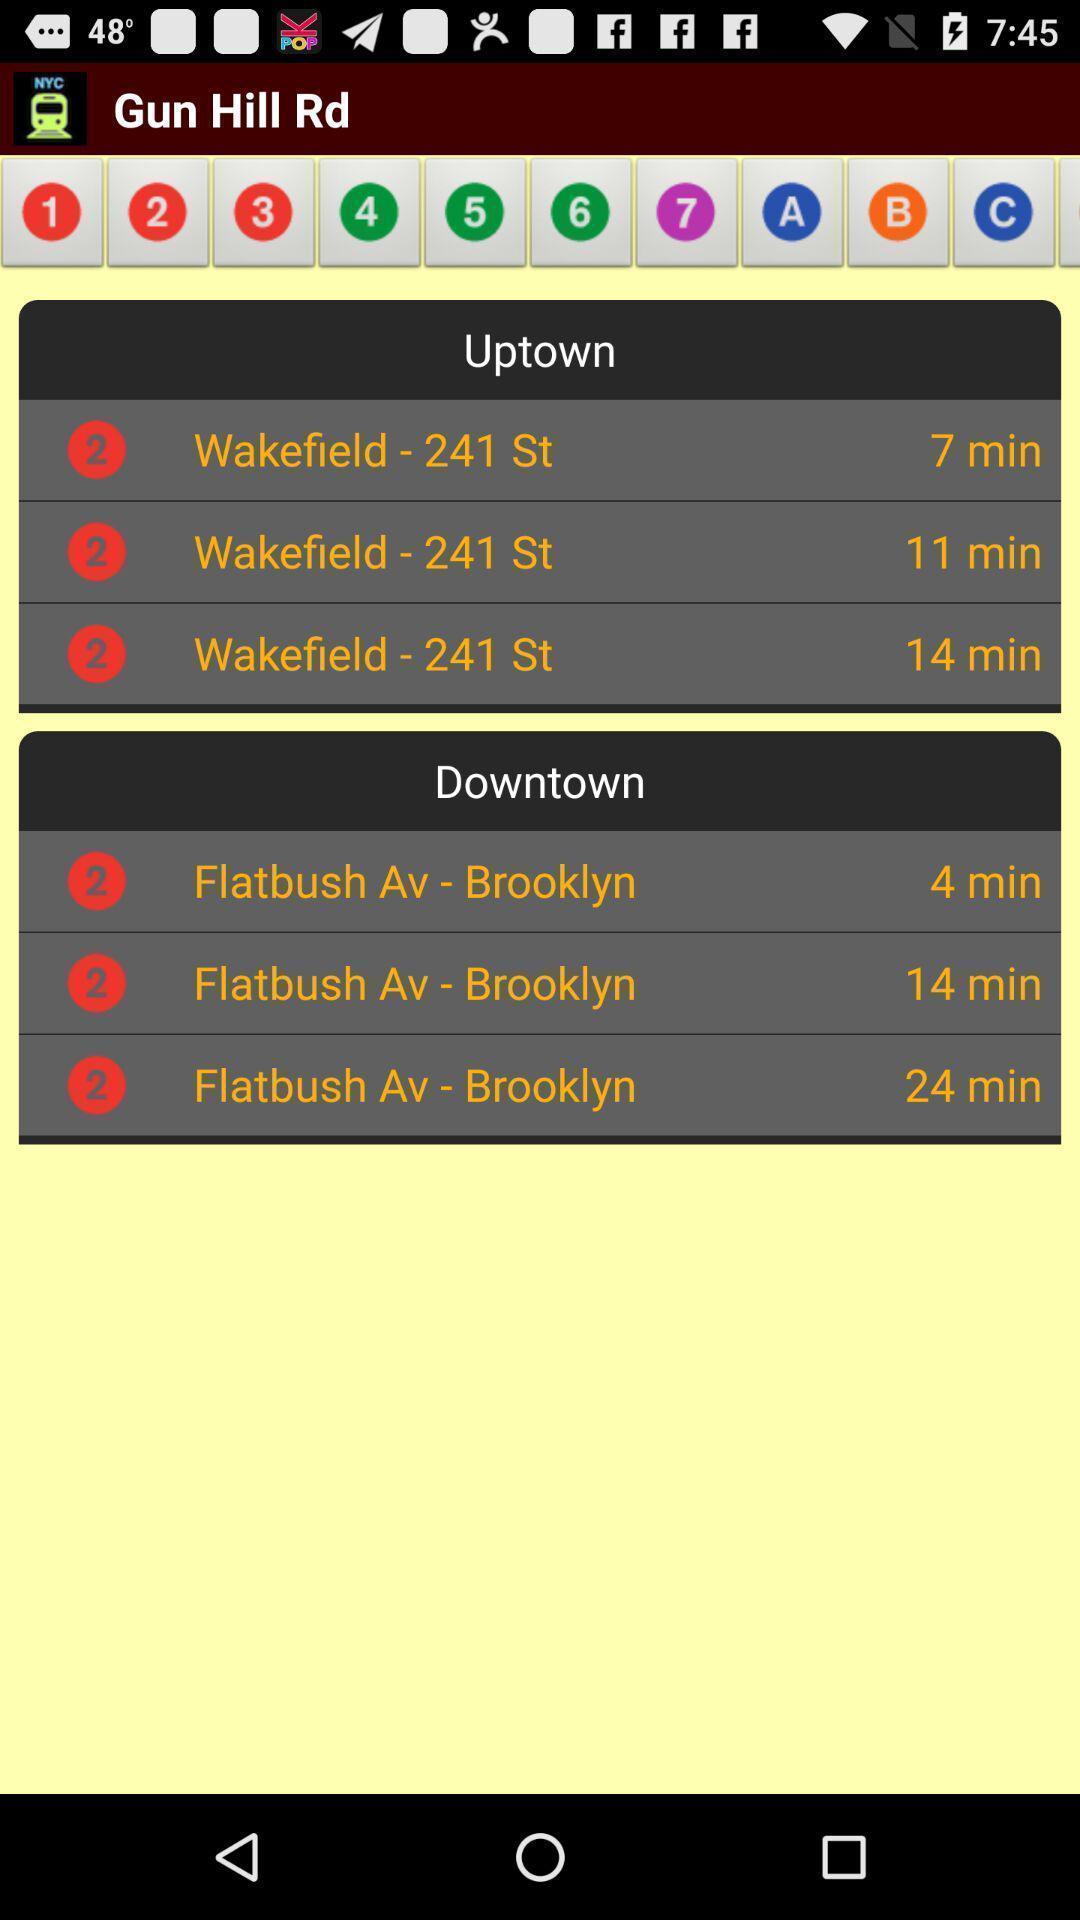Describe the visual elements of this screenshot. Screen displaying the information about the trains. 